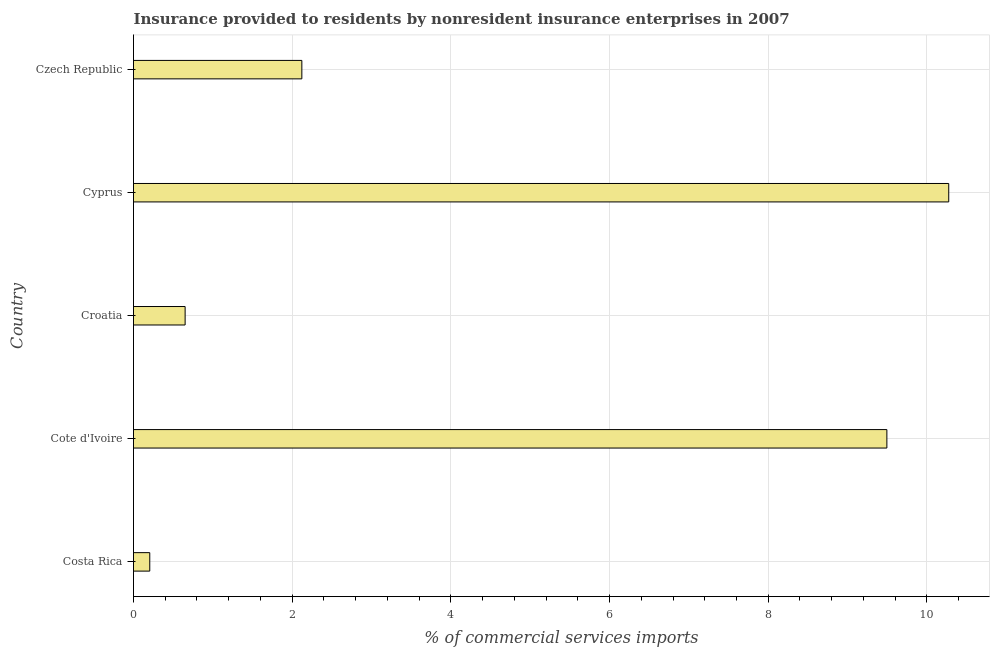What is the title of the graph?
Offer a very short reply. Insurance provided to residents by nonresident insurance enterprises in 2007. What is the label or title of the X-axis?
Your answer should be compact. % of commercial services imports. What is the insurance provided by non-residents in Czech Republic?
Offer a very short reply. 2.12. Across all countries, what is the maximum insurance provided by non-residents?
Make the answer very short. 10.28. Across all countries, what is the minimum insurance provided by non-residents?
Provide a succinct answer. 0.2. In which country was the insurance provided by non-residents maximum?
Provide a short and direct response. Cyprus. What is the sum of the insurance provided by non-residents?
Keep it short and to the point. 22.75. What is the difference between the insurance provided by non-residents in Cote d'Ivoire and Czech Republic?
Your answer should be compact. 7.37. What is the average insurance provided by non-residents per country?
Your answer should be very brief. 4.55. What is the median insurance provided by non-residents?
Keep it short and to the point. 2.12. What is the ratio of the insurance provided by non-residents in Costa Rica to that in Cyprus?
Give a very brief answer. 0.02. Is the insurance provided by non-residents in Cote d'Ivoire less than that in Croatia?
Give a very brief answer. No. Is the difference between the insurance provided by non-residents in Cote d'Ivoire and Croatia greater than the difference between any two countries?
Provide a short and direct response. No. What is the difference between the highest and the second highest insurance provided by non-residents?
Your response must be concise. 0.78. What is the difference between the highest and the lowest insurance provided by non-residents?
Provide a succinct answer. 10.07. In how many countries, is the insurance provided by non-residents greater than the average insurance provided by non-residents taken over all countries?
Your answer should be very brief. 2. How many bars are there?
Provide a succinct answer. 5. What is the difference between two consecutive major ticks on the X-axis?
Your response must be concise. 2. What is the % of commercial services imports in Costa Rica?
Ensure brevity in your answer.  0.2. What is the % of commercial services imports of Cote d'Ivoire?
Offer a terse response. 9.5. What is the % of commercial services imports in Croatia?
Offer a very short reply. 0.65. What is the % of commercial services imports of Cyprus?
Your response must be concise. 10.28. What is the % of commercial services imports in Czech Republic?
Keep it short and to the point. 2.12. What is the difference between the % of commercial services imports in Costa Rica and Cote d'Ivoire?
Give a very brief answer. -9.29. What is the difference between the % of commercial services imports in Costa Rica and Croatia?
Provide a succinct answer. -0.45. What is the difference between the % of commercial services imports in Costa Rica and Cyprus?
Give a very brief answer. -10.07. What is the difference between the % of commercial services imports in Costa Rica and Czech Republic?
Ensure brevity in your answer.  -1.92. What is the difference between the % of commercial services imports in Cote d'Ivoire and Croatia?
Your answer should be compact. 8.85. What is the difference between the % of commercial services imports in Cote d'Ivoire and Cyprus?
Provide a short and direct response. -0.78. What is the difference between the % of commercial services imports in Cote d'Ivoire and Czech Republic?
Ensure brevity in your answer.  7.37. What is the difference between the % of commercial services imports in Croatia and Cyprus?
Your answer should be compact. -9.62. What is the difference between the % of commercial services imports in Croatia and Czech Republic?
Provide a succinct answer. -1.47. What is the difference between the % of commercial services imports in Cyprus and Czech Republic?
Make the answer very short. 8.15. What is the ratio of the % of commercial services imports in Costa Rica to that in Cote d'Ivoire?
Your answer should be compact. 0.02. What is the ratio of the % of commercial services imports in Costa Rica to that in Croatia?
Give a very brief answer. 0.32. What is the ratio of the % of commercial services imports in Costa Rica to that in Cyprus?
Keep it short and to the point. 0.02. What is the ratio of the % of commercial services imports in Costa Rica to that in Czech Republic?
Provide a succinct answer. 0.1. What is the ratio of the % of commercial services imports in Cote d'Ivoire to that in Croatia?
Your response must be concise. 14.6. What is the ratio of the % of commercial services imports in Cote d'Ivoire to that in Cyprus?
Give a very brief answer. 0.92. What is the ratio of the % of commercial services imports in Cote d'Ivoire to that in Czech Republic?
Give a very brief answer. 4.48. What is the ratio of the % of commercial services imports in Croatia to that in Cyprus?
Your answer should be very brief. 0.06. What is the ratio of the % of commercial services imports in Croatia to that in Czech Republic?
Make the answer very short. 0.31. What is the ratio of the % of commercial services imports in Cyprus to that in Czech Republic?
Provide a succinct answer. 4.84. 